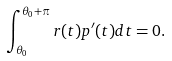Convert formula to latex. <formula><loc_0><loc_0><loc_500><loc_500>\int _ { \theta _ { 0 } } ^ { \theta _ { 0 } + \pi } r ( t ) p ^ { \prime } ( t ) d t = 0 .</formula> 